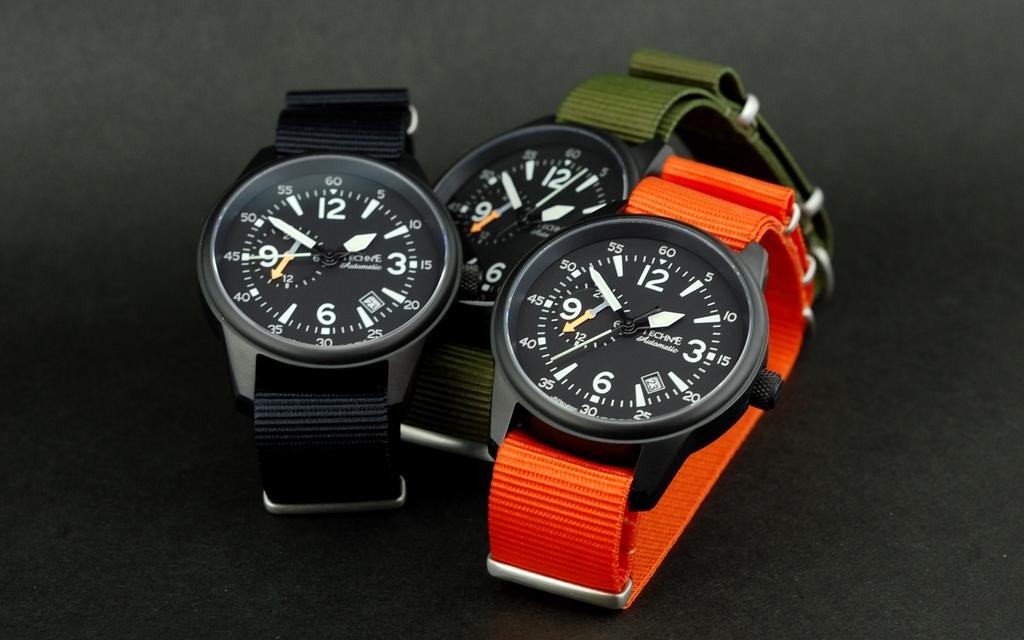What is the large number at the bottom of the watch faces?
Give a very brief answer. 6. 